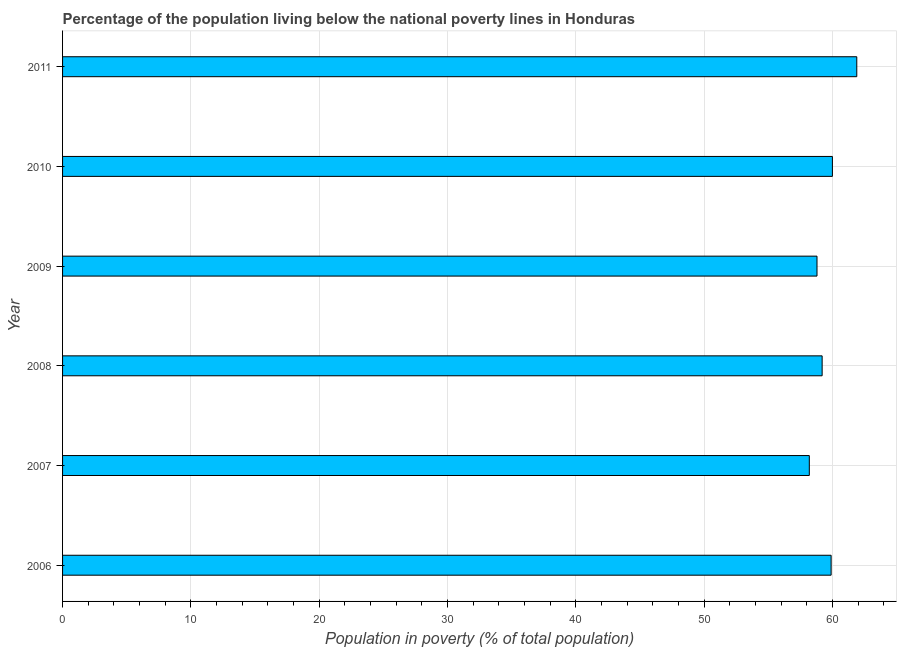Does the graph contain grids?
Provide a succinct answer. Yes. What is the title of the graph?
Offer a terse response. Percentage of the population living below the national poverty lines in Honduras. What is the label or title of the X-axis?
Your answer should be very brief. Population in poverty (% of total population). What is the percentage of population living below poverty line in 2009?
Your response must be concise. 58.8. Across all years, what is the maximum percentage of population living below poverty line?
Your answer should be very brief. 61.9. Across all years, what is the minimum percentage of population living below poverty line?
Your answer should be very brief. 58.2. In which year was the percentage of population living below poverty line minimum?
Keep it short and to the point. 2007. What is the sum of the percentage of population living below poverty line?
Provide a succinct answer. 358. What is the average percentage of population living below poverty line per year?
Your answer should be very brief. 59.67. What is the median percentage of population living below poverty line?
Ensure brevity in your answer.  59.55. What is the ratio of the percentage of population living below poverty line in 2010 to that in 2011?
Your answer should be very brief. 0.97. What is the difference between the highest and the second highest percentage of population living below poverty line?
Your response must be concise. 1.9. Is the sum of the percentage of population living below poverty line in 2008 and 2011 greater than the maximum percentage of population living below poverty line across all years?
Offer a very short reply. Yes. Are the values on the major ticks of X-axis written in scientific E-notation?
Keep it short and to the point. No. What is the Population in poverty (% of total population) of 2006?
Your answer should be very brief. 59.9. What is the Population in poverty (% of total population) in 2007?
Offer a terse response. 58.2. What is the Population in poverty (% of total population) in 2008?
Keep it short and to the point. 59.2. What is the Population in poverty (% of total population) of 2009?
Keep it short and to the point. 58.8. What is the Population in poverty (% of total population) in 2010?
Make the answer very short. 60. What is the Population in poverty (% of total population) of 2011?
Offer a very short reply. 61.9. What is the difference between the Population in poverty (% of total population) in 2006 and 2007?
Give a very brief answer. 1.7. What is the difference between the Population in poverty (% of total population) in 2006 and 2009?
Make the answer very short. 1.1. What is the difference between the Population in poverty (% of total population) in 2007 and 2009?
Your answer should be very brief. -0.6. What is the difference between the Population in poverty (% of total population) in 2007 and 2010?
Make the answer very short. -1.8. What is the difference between the Population in poverty (% of total population) in 2007 and 2011?
Provide a succinct answer. -3.7. What is the difference between the Population in poverty (% of total population) in 2009 and 2010?
Make the answer very short. -1.2. What is the difference between the Population in poverty (% of total population) in 2010 and 2011?
Your answer should be very brief. -1.9. What is the ratio of the Population in poverty (% of total population) in 2006 to that in 2007?
Ensure brevity in your answer.  1.03. What is the ratio of the Population in poverty (% of total population) in 2006 to that in 2008?
Make the answer very short. 1.01. What is the ratio of the Population in poverty (% of total population) in 2006 to that in 2009?
Offer a very short reply. 1.02. What is the ratio of the Population in poverty (% of total population) in 2006 to that in 2010?
Offer a very short reply. 1. What is the ratio of the Population in poverty (% of total population) in 2007 to that in 2008?
Your response must be concise. 0.98. What is the ratio of the Population in poverty (% of total population) in 2008 to that in 2009?
Keep it short and to the point. 1.01. What is the ratio of the Population in poverty (% of total population) in 2008 to that in 2011?
Offer a terse response. 0.96. What is the ratio of the Population in poverty (% of total population) in 2009 to that in 2010?
Provide a short and direct response. 0.98. What is the ratio of the Population in poverty (% of total population) in 2010 to that in 2011?
Provide a short and direct response. 0.97. 